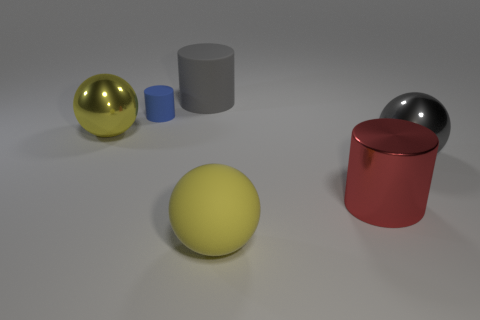There is a large matte sphere; is it the same color as the metallic sphere that is on the left side of the large yellow rubber thing?
Ensure brevity in your answer.  Yes. What shape is the thing that is the same color as the rubber sphere?
Your answer should be compact. Sphere. Do the shiny sphere that is on the left side of the tiny blue thing and the large matte ball have the same color?
Ensure brevity in your answer.  Yes. Is there anything else of the same color as the matte sphere?
Your response must be concise. Yes. What number of purple rubber objects are the same shape as the yellow metallic object?
Your response must be concise. 0. There is a metal ball that is right of the rubber object behind the small blue matte cylinder; what color is it?
Your answer should be very brief. Gray. There is a big red shiny thing; is its shape the same as the big matte thing right of the gray cylinder?
Provide a succinct answer. No. What material is the large ball to the left of the large yellow ball that is in front of the ball that is behind the large gray ball?
Your answer should be compact. Metal. Is there a red shiny block that has the same size as the yellow shiny thing?
Offer a terse response. No. What is the size of the other sphere that is made of the same material as the large gray ball?
Make the answer very short. Large. 